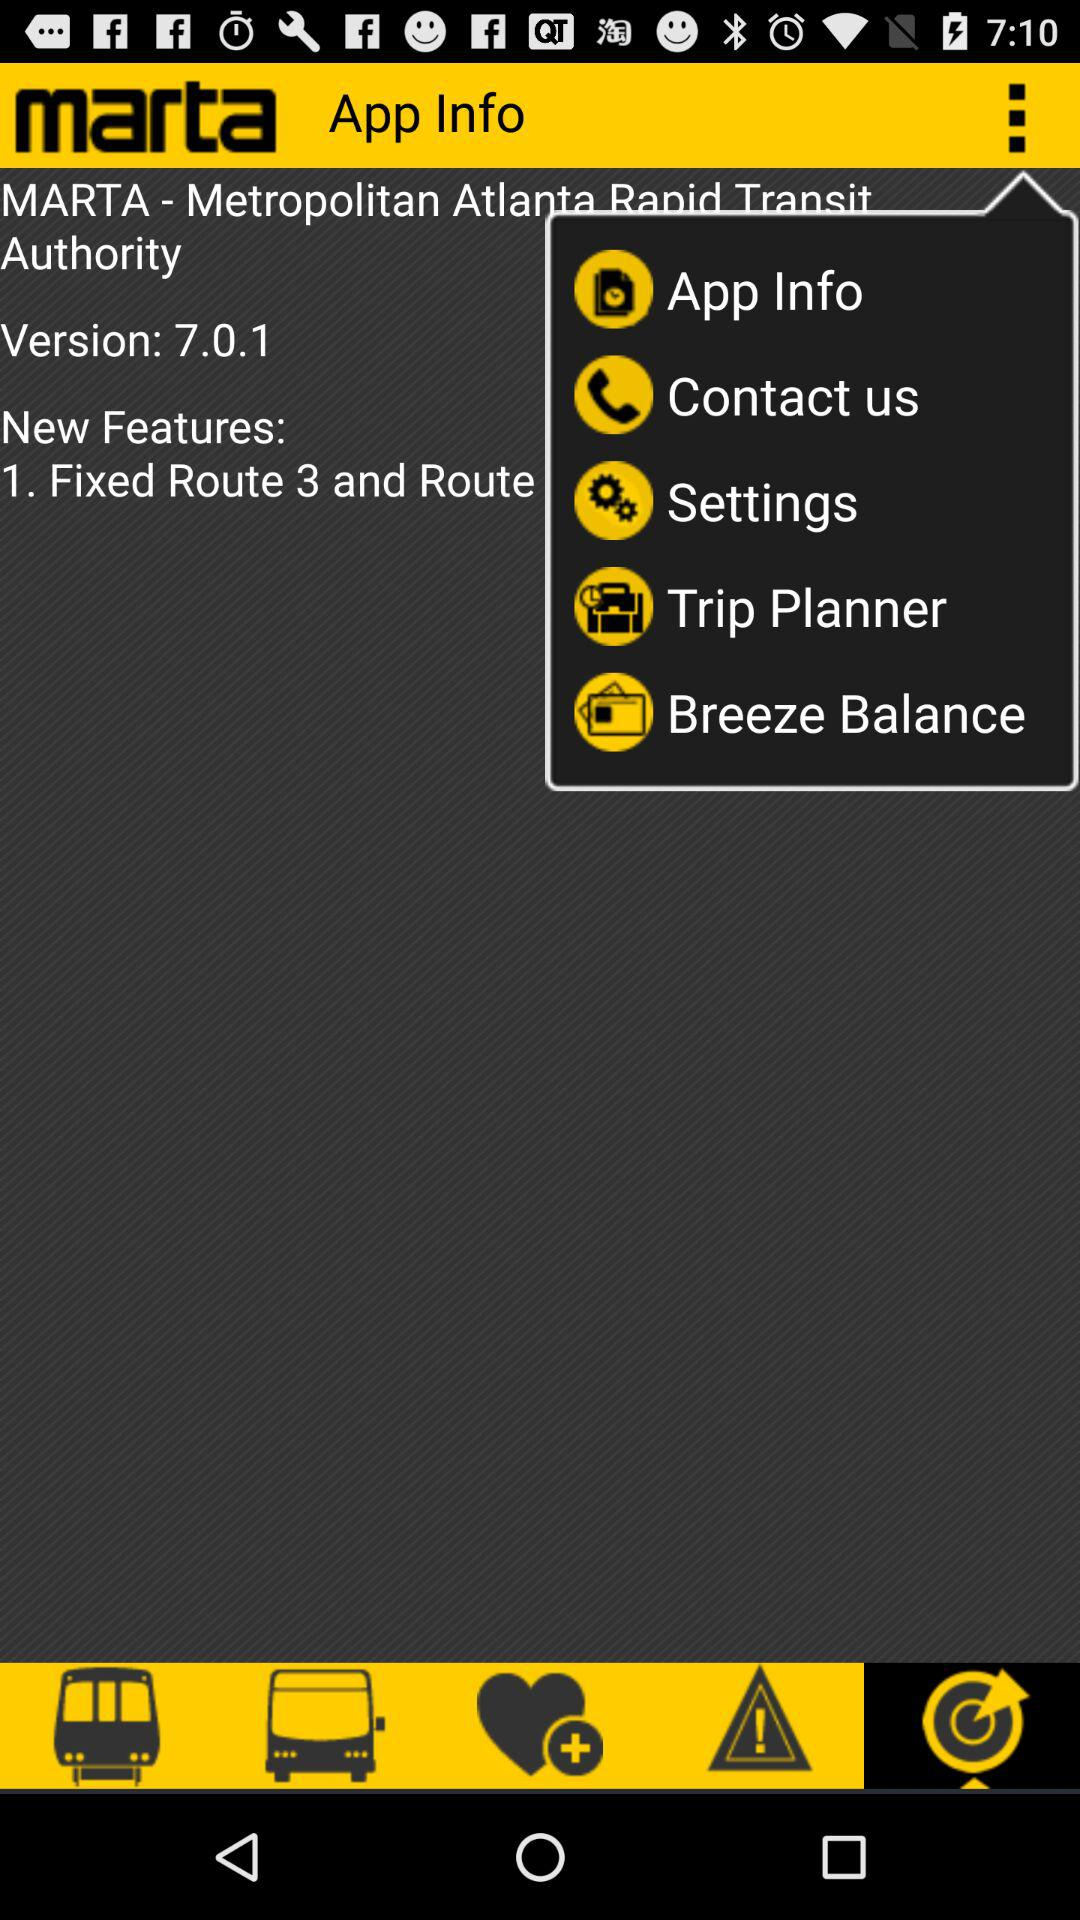What is the app name? The app name is "marta". 